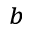<formula> <loc_0><loc_0><loc_500><loc_500>^ { b }</formula> 